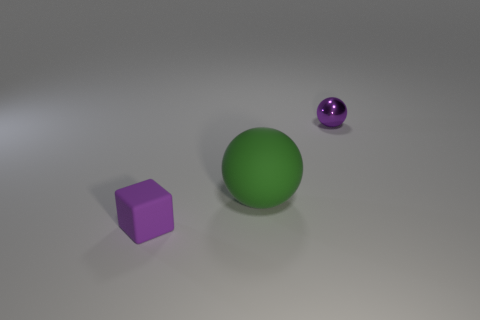Is there anything else that has the same size as the green matte object?
Your answer should be very brief. No. What number of small purple spheres are left of the ball that is on the left side of the tiny shiny thing behind the purple rubber object?
Give a very brief answer. 0. How big is the green matte thing?
Provide a succinct answer. Large. Is the small metallic thing the same color as the big thing?
Your answer should be compact. No. There is a ball on the left side of the small sphere; what is its size?
Provide a succinct answer. Large. Does the large matte thing to the left of the small purple sphere have the same color as the small object that is behind the tiny cube?
Give a very brief answer. No. What number of other objects are there of the same shape as the small matte object?
Make the answer very short. 0. Is the number of small purple rubber objects in front of the tiny rubber cube the same as the number of tiny rubber objects behind the large matte ball?
Ensure brevity in your answer.  Yes. Are the small thing behind the big thing and the tiny object that is to the left of the tiny shiny ball made of the same material?
Your response must be concise. No. How many other things are there of the same size as the purple matte block?
Your response must be concise. 1. 